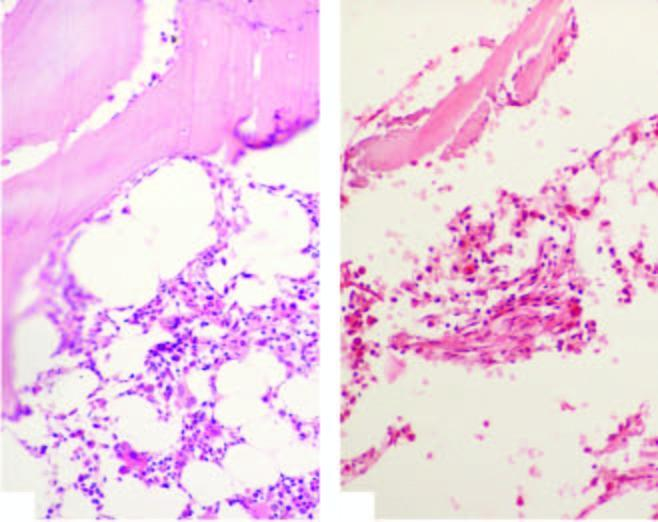what does the biopsy show?
Answer the question using a single word or phrase. Suppression of myeloid and erythroid cells and replacement of haematopoetic elements by fat in aplastic anaemia 